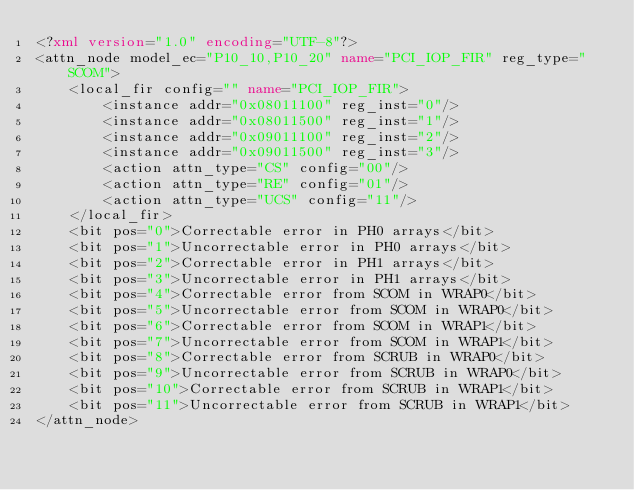Convert code to text. <code><loc_0><loc_0><loc_500><loc_500><_XML_><?xml version="1.0" encoding="UTF-8"?>
<attn_node model_ec="P10_10,P10_20" name="PCI_IOP_FIR" reg_type="SCOM">
    <local_fir config="" name="PCI_IOP_FIR">
        <instance addr="0x08011100" reg_inst="0"/>
        <instance addr="0x08011500" reg_inst="1"/>
        <instance addr="0x09011100" reg_inst="2"/>
        <instance addr="0x09011500" reg_inst="3"/>
        <action attn_type="CS" config="00"/>
        <action attn_type="RE" config="01"/>
        <action attn_type="UCS" config="11"/>
    </local_fir>
    <bit pos="0">Correctable error in PH0 arrays</bit>
    <bit pos="1">Uncorrectable error in PH0 arrays</bit>
    <bit pos="2">Correctable error in PH1 arrays</bit>
    <bit pos="3">Uncorrectable error in PH1 arrays</bit>
    <bit pos="4">Correctable error from SCOM in WRAP0</bit>
    <bit pos="5">Uncorrectable error from SCOM in WRAP0</bit>
    <bit pos="6">Correctable error from SCOM in WRAP1</bit>
    <bit pos="7">Uncorrectable error from SCOM in WRAP1</bit>
    <bit pos="8">Correctable error from SCRUB in WRAP0</bit>
    <bit pos="9">Uncorrectable error from SCRUB in WRAP0</bit>
    <bit pos="10">Correctable error from SCRUB in WRAP1</bit>
    <bit pos="11">Uncorrectable error from SCRUB in WRAP1</bit>
</attn_node>
</code> 